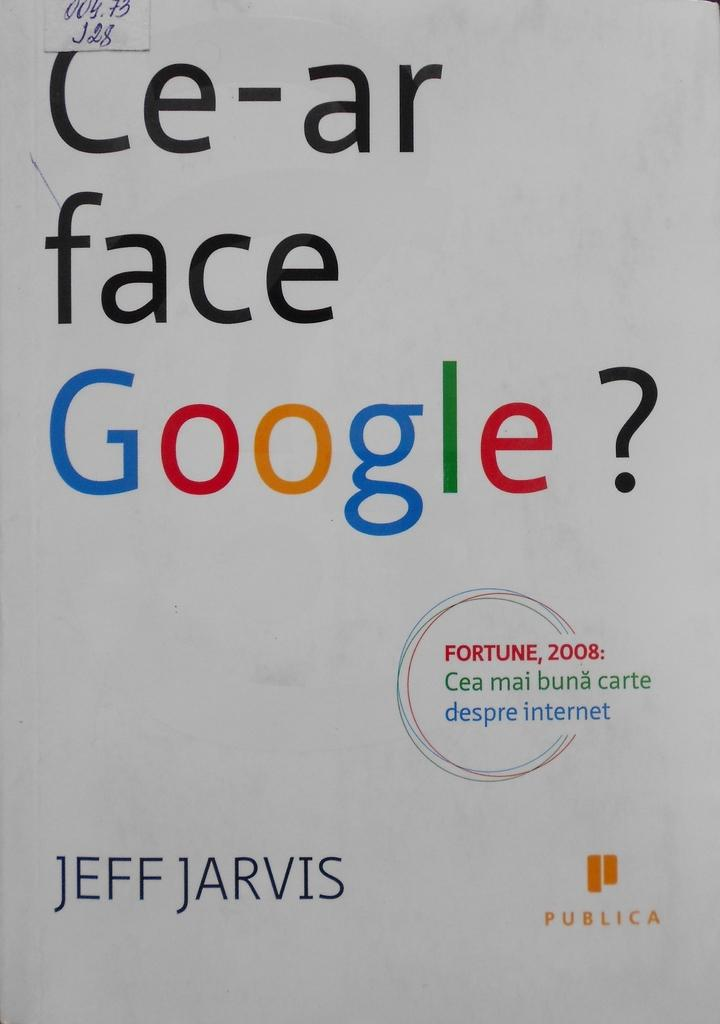<image>
Present a compact description of the photo's key features. The cover of a book about Google by Jeff Jarvis. 